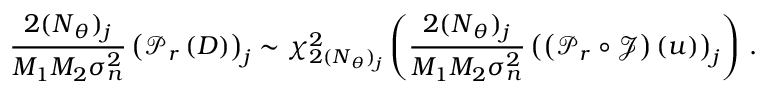<formula> <loc_0><loc_0><loc_500><loc_500>\frac { 2 ( N _ { \theta } ) _ { j } } { M _ { 1 } M _ { 2 } \sigma _ { n } ^ { 2 } } \left ( \mathcal { P } _ { r } \left ( D \right ) \right ) _ { j } \sim \chi _ { 2 ( N _ { \theta } ) _ { j } } ^ { 2 } \left ( \frac { 2 ( N _ { \theta } ) _ { j } } { M _ { 1 } M _ { 2 } \sigma _ { n } ^ { 2 } } \left ( \left ( \mathcal { P } _ { r } \circ \mathcal { J } \right ) \left ( u \right ) \right ) _ { j } \right ) \, .</formula> 